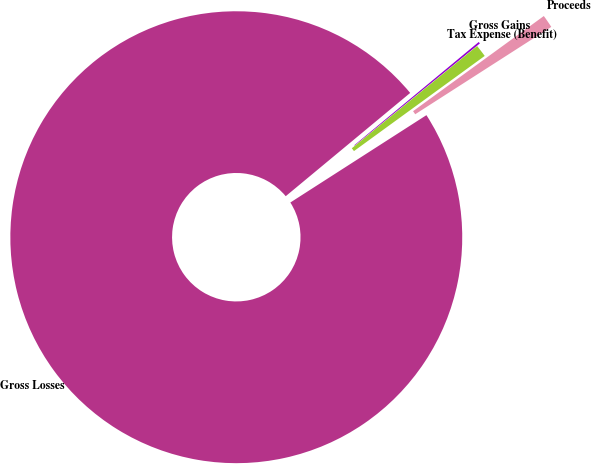Convert chart to OTSL. <chart><loc_0><loc_0><loc_500><loc_500><pie_chart><fcel>Gross Losses<fcel>Gross Gains<fcel>Tax Expense (Benefit)<fcel>Proceeds<nl><fcel>98.06%<fcel>0.13%<fcel>0.88%<fcel>0.93%<nl></chart> 